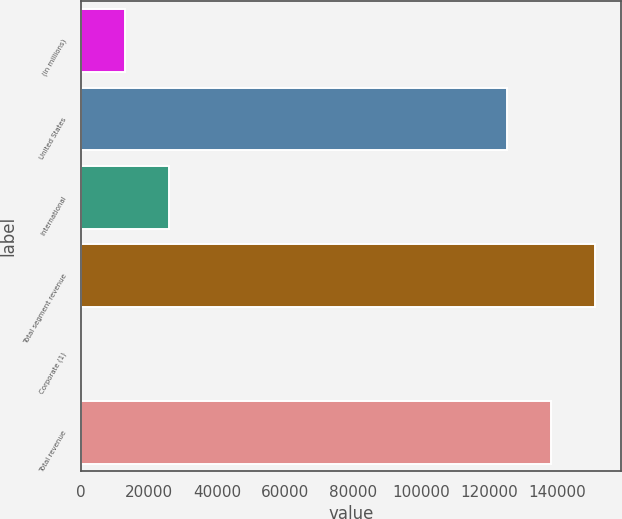<chart> <loc_0><loc_0><loc_500><loc_500><bar_chart><fcel>(in millions)<fcel>United States<fcel>International<fcel>Total segment revenue<fcel>Corporate (1)<fcel>Total revenue<nl><fcel>13008.6<fcel>125017<fcel>26006.2<fcel>151012<fcel>11<fcel>138015<nl></chart> 